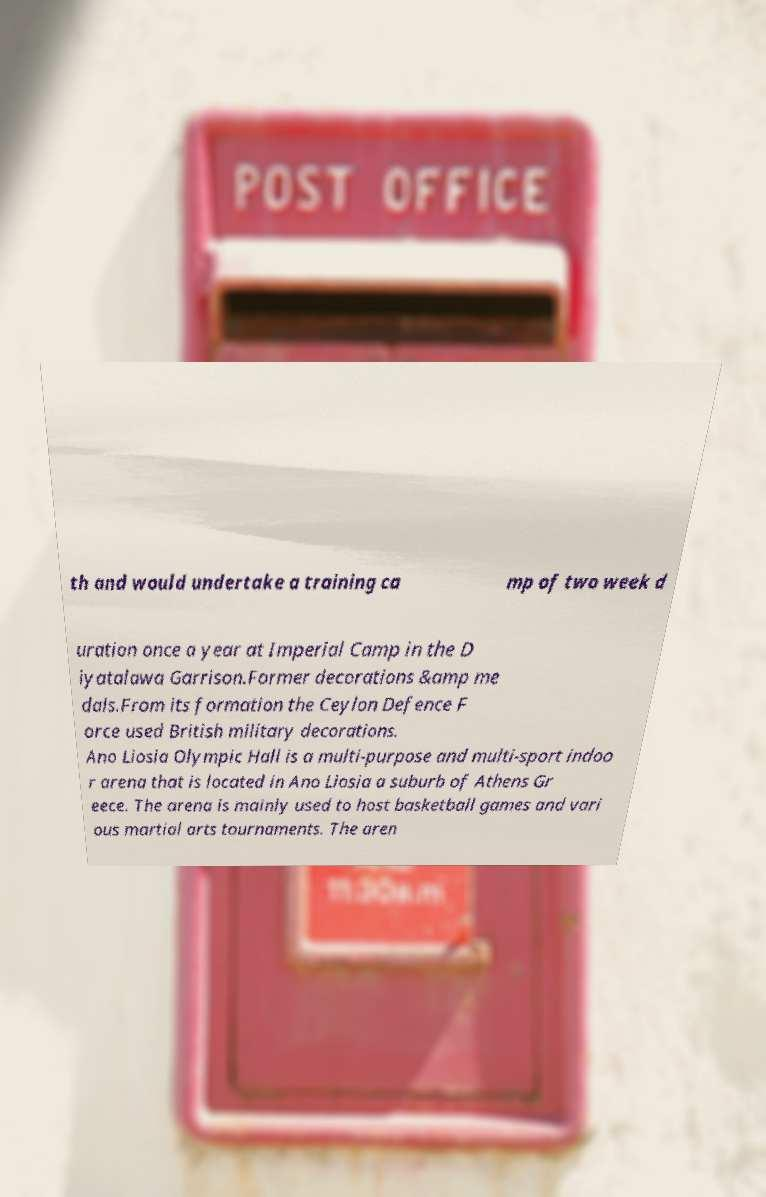I need the written content from this picture converted into text. Can you do that? th and would undertake a training ca mp of two week d uration once a year at Imperial Camp in the D iyatalawa Garrison.Former decorations &amp me dals.From its formation the Ceylon Defence F orce used British military decorations. Ano Liosia Olympic Hall is a multi-purpose and multi-sport indoo r arena that is located in Ano Liosia a suburb of Athens Gr eece. The arena is mainly used to host basketball games and vari ous martial arts tournaments. The aren 